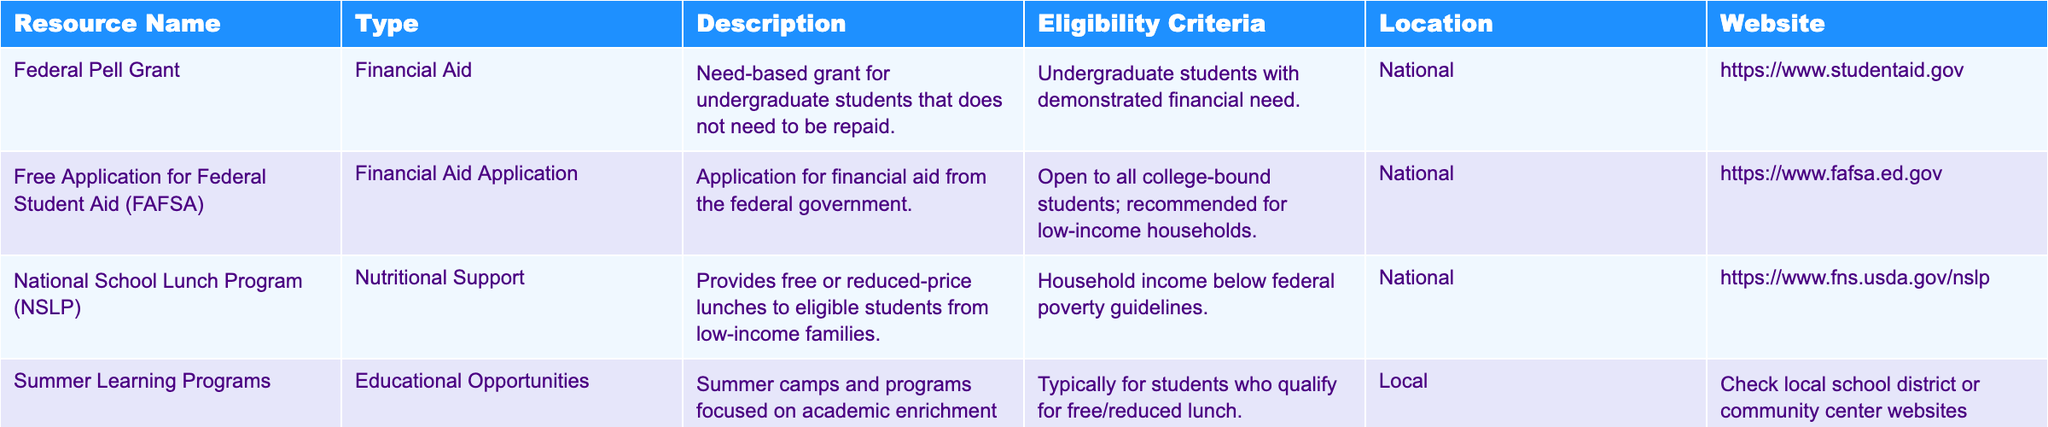What is the resource type of the Federal Pell Grant? The table lists the resource type for each entry under the "Type" column. Looking at the row for the Federal Pell Grant, it states that the type is "Financial Aid."
Answer: Financial Aid Who is eligible for the National School Lunch Program? The eligibility criteria for the National School Lunch Program are specified in the "Eligibility Criteria" column. It states that households must have an income below federal poverty guidelines.
Answer: Households with income below federal poverty guidelines How many educational resources listed provide financial aid? We can refer to the "Type" column and count how many entries are categorized as "Financial Aid." The Federal Pell Grant and FAFSA are the only entries under this type, which makes a total of 2.
Answer: 2 Is the Summer Learning Programs resource available nationally? To determine this, we look at the "Location" column for the Summer Learning Programs entry. It notes "Local," which indicates that it is not available nationally.
Answer: No What is the common eligibility criteria for the Federal Pell Grant and Summer Learning Programs? Both resources can be assessed for their eligibility criteria. The Federal Pell Grant requires demonstrated financial need while the Summer Learning Programs typically require qualification for free/reduced lunch. Thus, both resources target low-income students but with different specific criteria.
Answer: Low-income status What resources are available nationally? To find this, I will examine the "Location" column and identify which entries are marked as "National." The Federal Pell Grant, FAFSA, and National School Lunch Program are the three resources available nationally.
Answer: 3 Which resource has the description that emphasizes academic enrichment? By looking in the "Description" column, the entry that highlights academic enrichment specifically is the "Summer Learning Programs."
Answer: Summer Learning Programs If I want to apply for financial aid, which two specific resources should I consider? The "Type" column indicates financial aid resources including the Federal Pell Grant and FAFSA. Therefore, it’s most beneficial to consider these two.
Answer: Federal Pell Grant, FAFSA What is the primary function of the Free Application for Federal Student Aid (FAFSA)? The "Description" column provides insights into the FAFSA’s function, which is to serve as an application for financial aid from the federal government.
Answer: Application for financial aid Are any of the resources exclusively for undergraduate students? Looking at the "Eligibility Criteria," both the Federal Pell Grant is designated specifically for undergraduate students, while others are more general or local.
Answer: Yes, Federal Pell Grant 